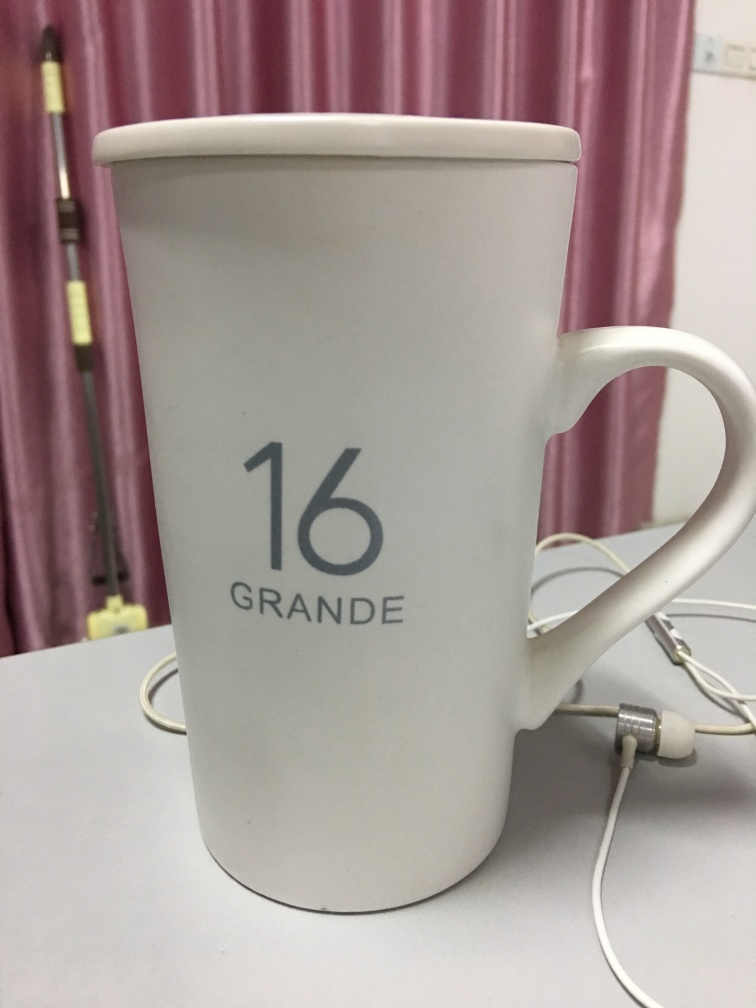What can you tell me about the item in the picture? The image showcases a white mug with the number '16' and the text 'GRANDE' printed on it. The mug is accompanied by earphones that are plugged into its handle, possibly suggesting a quirky way to keep them untangled. The mug seems to be placed on a flat surface with a pale pink curtain in the background, indicating an indoor setting, perhaps a home or office environment. 